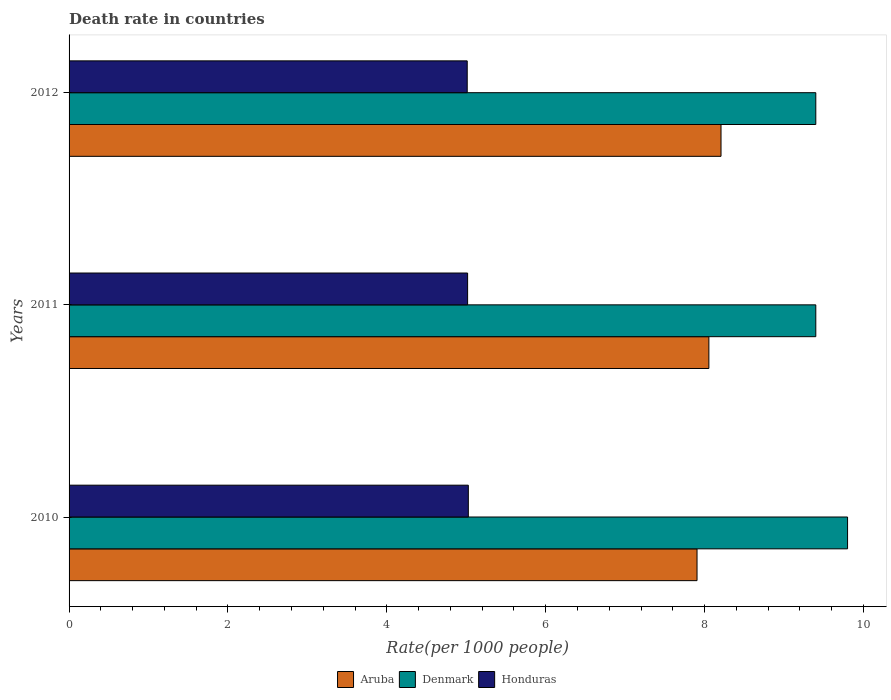Are the number of bars on each tick of the Y-axis equal?
Offer a terse response. Yes. What is the label of the 2nd group of bars from the top?
Provide a short and direct response. 2011. What is the death rate in Aruba in 2012?
Your answer should be very brief. 8.21. Across all years, what is the maximum death rate in Aruba?
Ensure brevity in your answer.  8.21. Across all years, what is the minimum death rate in Honduras?
Give a very brief answer. 5.01. In which year was the death rate in Denmark minimum?
Provide a short and direct response. 2011. What is the total death rate in Denmark in the graph?
Provide a succinct answer. 28.6. What is the difference between the death rate in Aruba in 2010 and that in 2012?
Your answer should be very brief. -0.3. What is the difference between the death rate in Denmark in 2010 and the death rate in Honduras in 2012?
Your answer should be very brief. 4.79. What is the average death rate in Honduras per year?
Ensure brevity in your answer.  5.02. In the year 2012, what is the difference between the death rate in Honduras and death rate in Denmark?
Provide a short and direct response. -4.39. In how many years, is the death rate in Aruba greater than 2 ?
Offer a terse response. 3. What is the ratio of the death rate in Denmark in 2010 to that in 2012?
Make the answer very short. 1.04. Is the difference between the death rate in Honduras in 2010 and 2012 greater than the difference between the death rate in Denmark in 2010 and 2012?
Your answer should be compact. No. What is the difference between the highest and the second highest death rate in Denmark?
Provide a short and direct response. 0.4. What is the difference between the highest and the lowest death rate in Denmark?
Provide a succinct answer. 0.4. In how many years, is the death rate in Honduras greater than the average death rate in Honduras taken over all years?
Provide a short and direct response. 1. What does the 1st bar from the top in 2010 represents?
Provide a succinct answer. Honduras. What does the 2nd bar from the bottom in 2010 represents?
Give a very brief answer. Denmark. Is it the case that in every year, the sum of the death rate in Aruba and death rate in Denmark is greater than the death rate in Honduras?
Your answer should be very brief. Yes. How many bars are there?
Keep it short and to the point. 9. How many years are there in the graph?
Your answer should be compact. 3. Are the values on the major ticks of X-axis written in scientific E-notation?
Provide a short and direct response. No. Does the graph contain any zero values?
Your response must be concise. No. Does the graph contain grids?
Keep it short and to the point. No. Where does the legend appear in the graph?
Offer a terse response. Bottom center. How many legend labels are there?
Provide a succinct answer. 3. How are the legend labels stacked?
Your answer should be compact. Horizontal. What is the title of the graph?
Offer a terse response. Death rate in countries. What is the label or title of the X-axis?
Give a very brief answer. Rate(per 1000 people). What is the Rate(per 1000 people) in Aruba in 2010?
Keep it short and to the point. 7.91. What is the Rate(per 1000 people) in Honduras in 2010?
Make the answer very short. 5.03. What is the Rate(per 1000 people) in Aruba in 2011?
Your answer should be compact. 8.05. What is the Rate(per 1000 people) of Denmark in 2011?
Give a very brief answer. 9.4. What is the Rate(per 1000 people) of Honduras in 2011?
Ensure brevity in your answer.  5.02. What is the Rate(per 1000 people) of Aruba in 2012?
Provide a succinct answer. 8.21. What is the Rate(per 1000 people) in Denmark in 2012?
Give a very brief answer. 9.4. What is the Rate(per 1000 people) in Honduras in 2012?
Your answer should be compact. 5.01. Across all years, what is the maximum Rate(per 1000 people) in Aruba?
Provide a short and direct response. 8.21. Across all years, what is the maximum Rate(per 1000 people) of Honduras?
Your response must be concise. 5.03. Across all years, what is the minimum Rate(per 1000 people) of Aruba?
Your response must be concise. 7.91. Across all years, what is the minimum Rate(per 1000 people) of Honduras?
Your answer should be compact. 5.01. What is the total Rate(per 1000 people) of Aruba in the graph?
Give a very brief answer. 24.17. What is the total Rate(per 1000 people) in Denmark in the graph?
Your answer should be very brief. 28.6. What is the total Rate(per 1000 people) of Honduras in the graph?
Your answer should be very brief. 15.05. What is the difference between the Rate(per 1000 people) of Aruba in 2010 and that in 2011?
Make the answer very short. -0.15. What is the difference between the Rate(per 1000 people) of Denmark in 2010 and that in 2011?
Give a very brief answer. 0.4. What is the difference between the Rate(per 1000 people) in Honduras in 2010 and that in 2011?
Keep it short and to the point. 0.01. What is the difference between the Rate(per 1000 people) in Aruba in 2010 and that in 2012?
Keep it short and to the point. -0.3. What is the difference between the Rate(per 1000 people) of Honduras in 2010 and that in 2012?
Your answer should be compact. 0.01. What is the difference between the Rate(per 1000 people) in Aruba in 2011 and that in 2012?
Offer a terse response. -0.15. What is the difference between the Rate(per 1000 people) in Honduras in 2011 and that in 2012?
Provide a succinct answer. 0.01. What is the difference between the Rate(per 1000 people) of Aruba in 2010 and the Rate(per 1000 people) of Denmark in 2011?
Provide a succinct answer. -1.5. What is the difference between the Rate(per 1000 people) in Aruba in 2010 and the Rate(per 1000 people) in Honduras in 2011?
Provide a short and direct response. 2.89. What is the difference between the Rate(per 1000 people) in Denmark in 2010 and the Rate(per 1000 people) in Honduras in 2011?
Give a very brief answer. 4.78. What is the difference between the Rate(per 1000 people) of Aruba in 2010 and the Rate(per 1000 people) of Denmark in 2012?
Provide a succinct answer. -1.5. What is the difference between the Rate(per 1000 people) in Aruba in 2010 and the Rate(per 1000 people) in Honduras in 2012?
Your answer should be very brief. 2.89. What is the difference between the Rate(per 1000 people) in Denmark in 2010 and the Rate(per 1000 people) in Honduras in 2012?
Make the answer very short. 4.79. What is the difference between the Rate(per 1000 people) in Aruba in 2011 and the Rate(per 1000 people) in Denmark in 2012?
Provide a succinct answer. -1.35. What is the difference between the Rate(per 1000 people) in Aruba in 2011 and the Rate(per 1000 people) in Honduras in 2012?
Ensure brevity in your answer.  3.04. What is the difference between the Rate(per 1000 people) of Denmark in 2011 and the Rate(per 1000 people) of Honduras in 2012?
Your response must be concise. 4.39. What is the average Rate(per 1000 people) of Aruba per year?
Ensure brevity in your answer.  8.06. What is the average Rate(per 1000 people) in Denmark per year?
Keep it short and to the point. 9.53. What is the average Rate(per 1000 people) of Honduras per year?
Your answer should be compact. 5.02. In the year 2010, what is the difference between the Rate(per 1000 people) in Aruba and Rate(per 1000 people) in Denmark?
Offer a terse response. -1.9. In the year 2010, what is the difference between the Rate(per 1000 people) in Aruba and Rate(per 1000 people) in Honduras?
Your answer should be very brief. 2.88. In the year 2010, what is the difference between the Rate(per 1000 people) in Denmark and Rate(per 1000 people) in Honduras?
Keep it short and to the point. 4.77. In the year 2011, what is the difference between the Rate(per 1000 people) of Aruba and Rate(per 1000 people) of Denmark?
Offer a terse response. -1.35. In the year 2011, what is the difference between the Rate(per 1000 people) of Aruba and Rate(per 1000 people) of Honduras?
Provide a short and direct response. 3.04. In the year 2011, what is the difference between the Rate(per 1000 people) in Denmark and Rate(per 1000 people) in Honduras?
Offer a terse response. 4.38. In the year 2012, what is the difference between the Rate(per 1000 people) of Aruba and Rate(per 1000 people) of Denmark?
Ensure brevity in your answer.  -1.19. In the year 2012, what is the difference between the Rate(per 1000 people) in Aruba and Rate(per 1000 people) in Honduras?
Provide a short and direct response. 3.19. In the year 2012, what is the difference between the Rate(per 1000 people) in Denmark and Rate(per 1000 people) in Honduras?
Make the answer very short. 4.39. What is the ratio of the Rate(per 1000 people) in Aruba in 2010 to that in 2011?
Make the answer very short. 0.98. What is the ratio of the Rate(per 1000 people) of Denmark in 2010 to that in 2011?
Your answer should be compact. 1.04. What is the ratio of the Rate(per 1000 people) in Honduras in 2010 to that in 2011?
Your answer should be very brief. 1. What is the ratio of the Rate(per 1000 people) of Aruba in 2010 to that in 2012?
Provide a succinct answer. 0.96. What is the ratio of the Rate(per 1000 people) of Denmark in 2010 to that in 2012?
Your answer should be compact. 1.04. What is the ratio of the Rate(per 1000 people) in Honduras in 2010 to that in 2012?
Your response must be concise. 1. What is the ratio of the Rate(per 1000 people) in Aruba in 2011 to that in 2012?
Your response must be concise. 0.98. What is the ratio of the Rate(per 1000 people) in Denmark in 2011 to that in 2012?
Your response must be concise. 1. What is the difference between the highest and the second highest Rate(per 1000 people) in Aruba?
Offer a very short reply. 0.15. What is the difference between the highest and the second highest Rate(per 1000 people) in Denmark?
Offer a very short reply. 0.4. What is the difference between the highest and the second highest Rate(per 1000 people) of Honduras?
Keep it short and to the point. 0.01. What is the difference between the highest and the lowest Rate(per 1000 people) in Aruba?
Keep it short and to the point. 0.3. What is the difference between the highest and the lowest Rate(per 1000 people) in Denmark?
Provide a short and direct response. 0.4. What is the difference between the highest and the lowest Rate(per 1000 people) of Honduras?
Your answer should be compact. 0.01. 